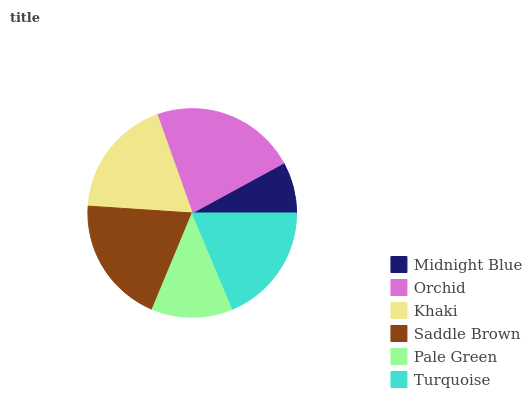Is Midnight Blue the minimum?
Answer yes or no. Yes. Is Orchid the maximum?
Answer yes or no. Yes. Is Khaki the minimum?
Answer yes or no. No. Is Khaki the maximum?
Answer yes or no. No. Is Orchid greater than Khaki?
Answer yes or no. Yes. Is Khaki less than Orchid?
Answer yes or no. Yes. Is Khaki greater than Orchid?
Answer yes or no. No. Is Orchid less than Khaki?
Answer yes or no. No. Is Turquoise the high median?
Answer yes or no. Yes. Is Khaki the low median?
Answer yes or no. Yes. Is Saddle Brown the high median?
Answer yes or no. No. Is Pale Green the low median?
Answer yes or no. No. 